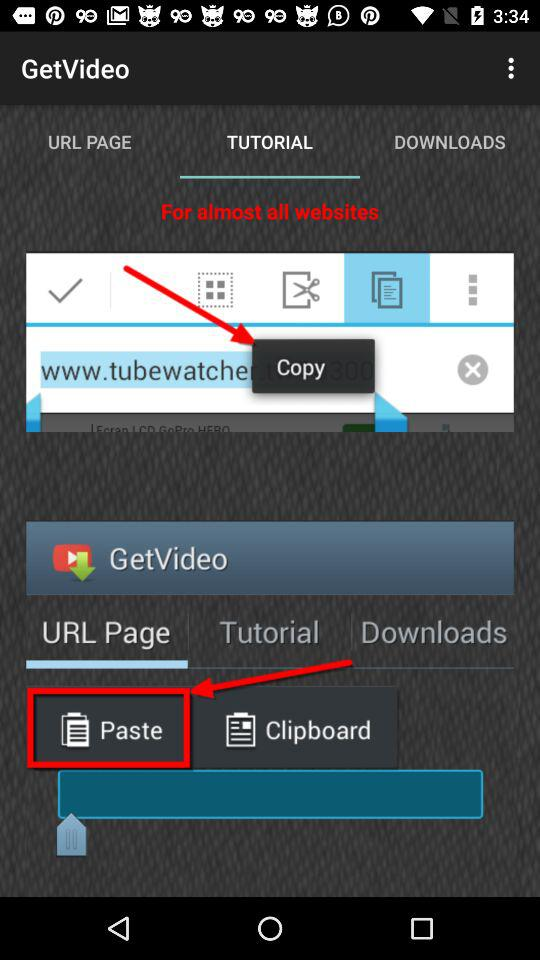Which tab is selected? The selected tab is "TUTORIAL". 